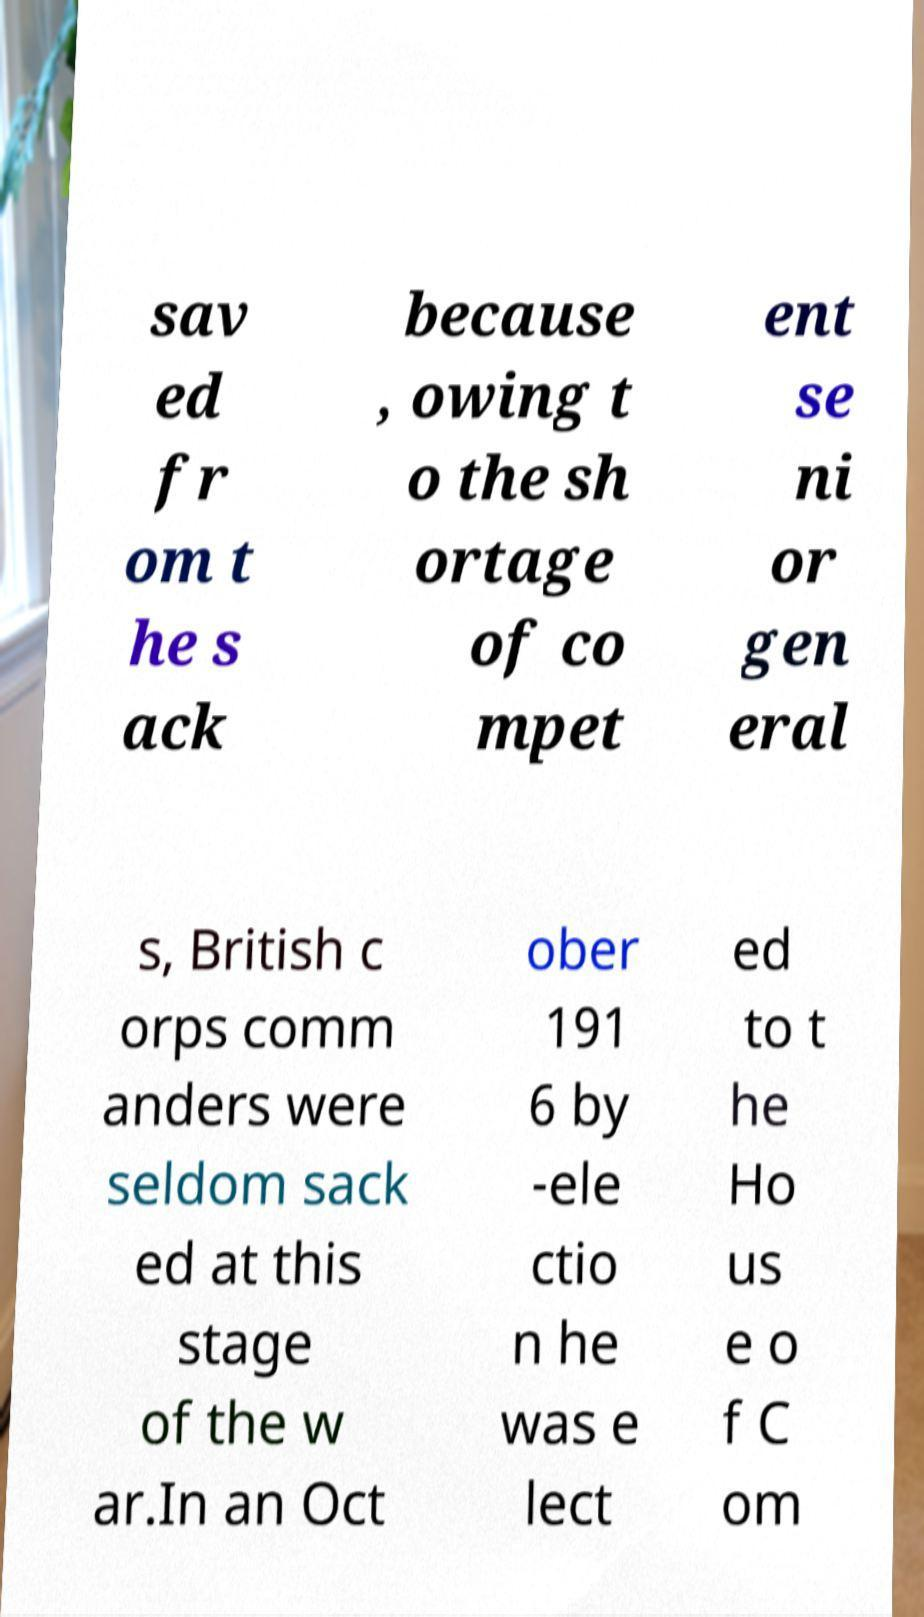There's text embedded in this image that I need extracted. Can you transcribe it verbatim? sav ed fr om t he s ack because , owing t o the sh ortage of co mpet ent se ni or gen eral s, British c orps comm anders were seldom sack ed at this stage of the w ar.In an Oct ober 191 6 by -ele ctio n he was e lect ed to t he Ho us e o f C om 